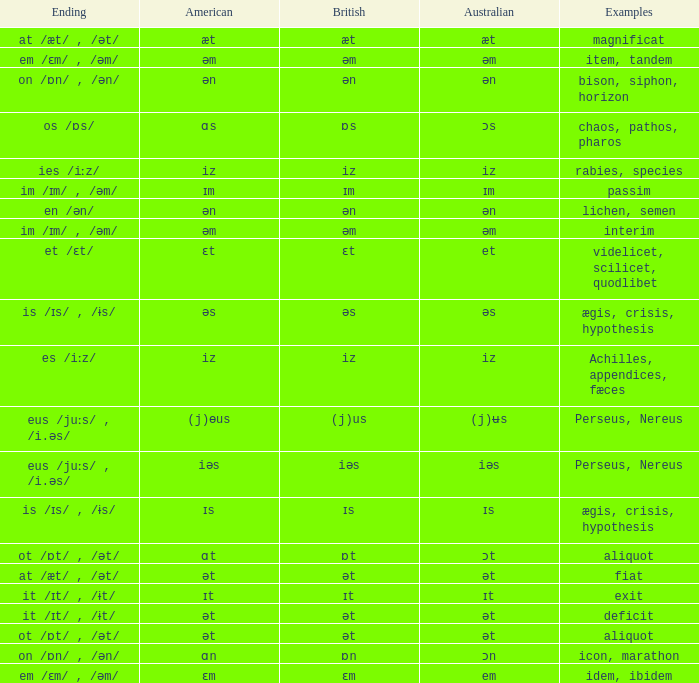Parse the full table. {'header': ['Ending', 'American', 'British', 'Australian', 'Examples'], 'rows': [['at /æt/ , /ət/', 'æt', 'æt', 'æt', 'magnificat'], ['em /ɛm/ , /əm/', 'əm', 'əm', 'əm', 'item, tandem'], ['on /ɒn/ , /ən/', 'ən', 'ən', 'ən', 'bison, siphon, horizon'], ['os /ɒs/', 'ɑs', 'ɒs', 'ɔs', 'chaos, pathos, pharos'], ['ies /iːz/', 'iz', 'iz', 'iz', 'rabies, species'], ['im /ɪm/ , /əm/', 'ɪm', 'ɪm', 'ɪm', 'passim'], ['en /ən/', 'ən', 'ən', 'ən', 'lichen, semen'], ['im /ɪm/ , /əm/', 'əm', 'əm', 'əm', 'interim'], ['et /ɛt/', 'ɛt', 'ɛt', 'et', 'videlicet, scilicet, quodlibet'], ['is /ɪs/ , /ɨs/', 'əs', 'əs', 'əs', 'ægis, crisis, hypothesis'], ['es /iːz/', 'iz', 'iz', 'iz', 'Achilles, appendices, fæces'], ['eus /juːs/ , /i.əs/', '(j)ɵus', '(j)us', '(j)ʉs', 'Perseus, Nereus'], ['eus /juːs/ , /i.əs/', 'iəs', 'iəs', 'iəs', 'Perseus, Nereus'], ['is /ɪs/ , /ɨs/', 'ɪs', 'ɪs', 'ɪs', 'ægis, crisis, hypothesis'], ['ot /ɒt/ , /ət/', 'ɑt', 'ɒt', 'ɔt', 'aliquot'], ['at /æt/ , /ət/', 'ət', 'ət', 'ət', 'fiat'], ['it /ɪt/ , /ɨt/', 'ɪt', 'ɪt', 'ɪt', 'exit'], ['it /ɪt/ , /ɨt/', 'ət', 'ət', 'ət', 'deficit'], ['ot /ɒt/ , /ət/', 'ət', 'ət', 'ət', 'aliquot'], ['on /ɒn/ , /ən/', 'ɑn', 'ɒn', 'ɔn', 'icon, marathon'], ['em /ɛm/ , /əm/', 'ɛm', 'ɛm', 'em', 'idem, ibidem']]} Which American has British of ɛm? Ɛm. 